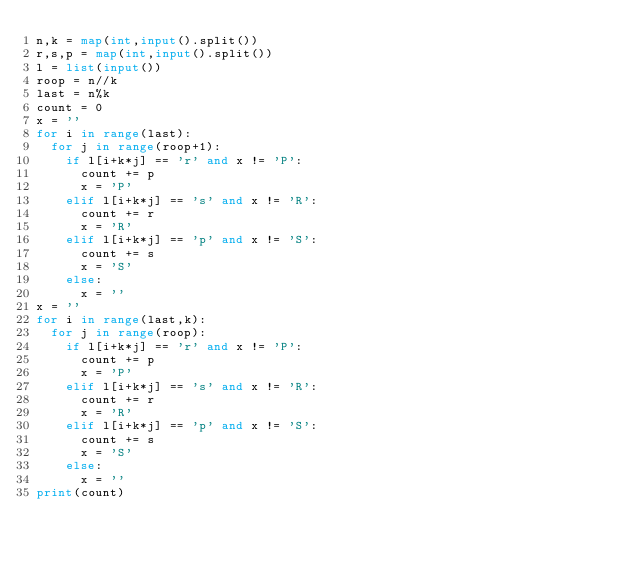Convert code to text. <code><loc_0><loc_0><loc_500><loc_500><_Python_>n,k = map(int,input().split())
r,s,p = map(int,input().split())
l = list(input())
roop = n//k
last = n%k
count = 0
x = ''
for i in range(last):
  for j in range(roop+1):
    if l[i+k*j] == 'r' and x != 'P':
      count += p
      x = 'P'
    elif l[i+k*j] == 's' and x != 'R':
      count += r
      x = 'R'
    elif l[i+k*j] == 'p' and x != 'S':
      count += s
      x = 'S'
    else:
      x = ''
x = ''
for i in range(last,k):
  for j in range(roop):
    if l[i+k*j] == 'r' and x != 'P':
      count += p
      x = 'P'
    elif l[i+k*j] == 's' and x != 'R':
      count += r
      x = 'R'
    elif l[i+k*j] == 'p' and x != 'S':
      count += s
      x = 'S'
    else:
      x = ''
print(count)
</code> 